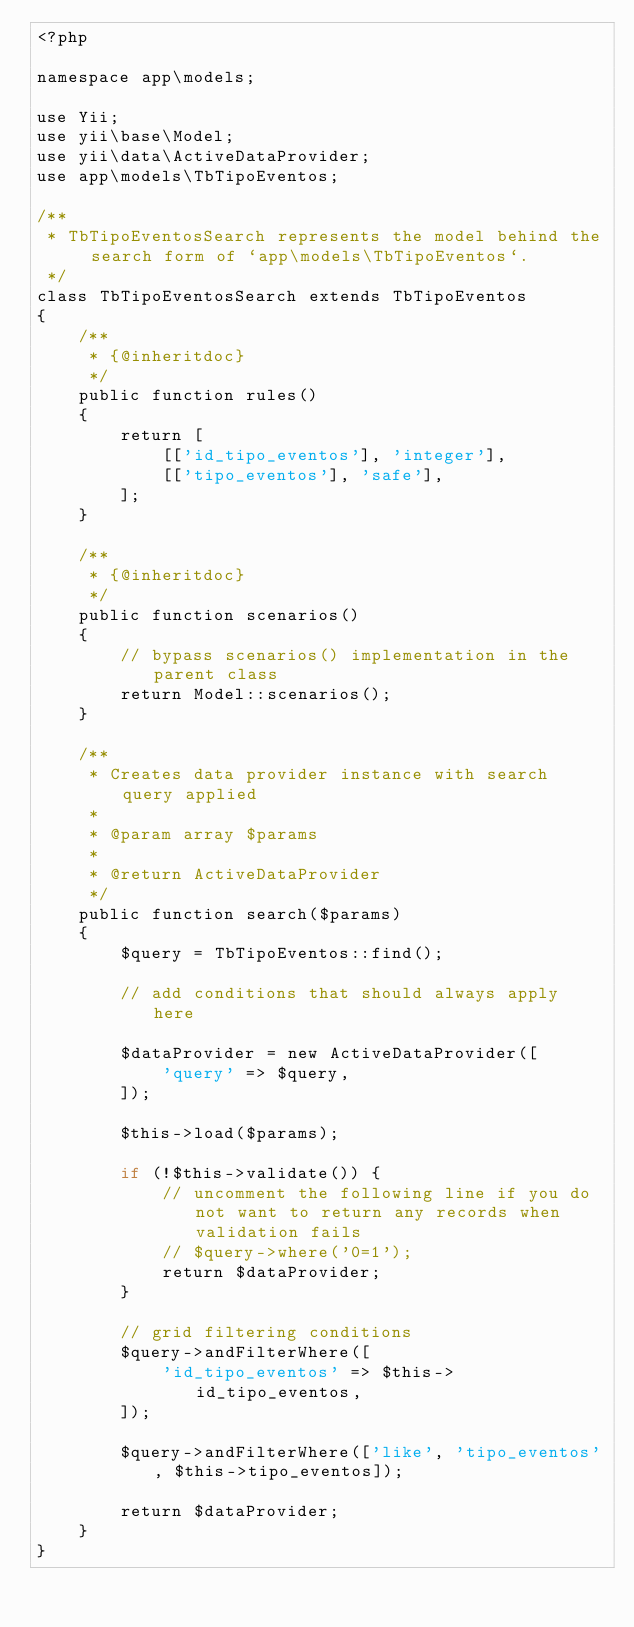<code> <loc_0><loc_0><loc_500><loc_500><_PHP_><?php

namespace app\models;

use Yii;
use yii\base\Model;
use yii\data\ActiveDataProvider;
use app\models\TbTipoEventos;

/**
 * TbTipoEventosSearch represents the model behind the search form of `app\models\TbTipoEventos`.
 */
class TbTipoEventosSearch extends TbTipoEventos
{
    /**
     * {@inheritdoc}
     */
    public function rules()
    {
        return [
            [['id_tipo_eventos'], 'integer'],
            [['tipo_eventos'], 'safe'],
        ];
    }

    /**
     * {@inheritdoc}
     */
    public function scenarios()
    {
        // bypass scenarios() implementation in the parent class
        return Model::scenarios();
    }

    /**
     * Creates data provider instance with search query applied
     *
     * @param array $params
     *
     * @return ActiveDataProvider
     */
    public function search($params)
    {
        $query = TbTipoEventos::find();

        // add conditions that should always apply here

        $dataProvider = new ActiveDataProvider([
            'query' => $query,
        ]);

        $this->load($params);

        if (!$this->validate()) {
            // uncomment the following line if you do not want to return any records when validation fails
            // $query->where('0=1');
            return $dataProvider;
        }

        // grid filtering conditions
        $query->andFilterWhere([
            'id_tipo_eventos' => $this->id_tipo_eventos,
        ]);

        $query->andFilterWhere(['like', 'tipo_eventos', $this->tipo_eventos]);

        return $dataProvider;
    }
}
</code> 